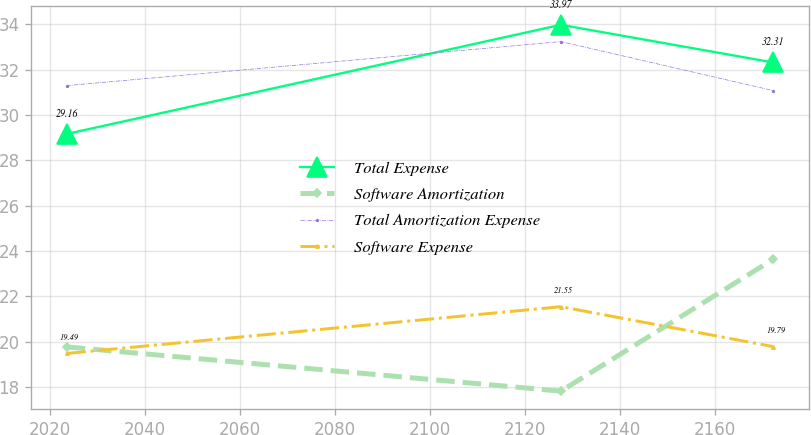Convert chart to OTSL. <chart><loc_0><loc_0><loc_500><loc_500><line_chart><ecel><fcel>Total Expense<fcel>Software Amortization<fcel>Total Amortization Expense<fcel>Software Expense<nl><fcel>2023.6<fcel>29.16<fcel>19.78<fcel>31.29<fcel>19.49<nl><fcel>2127.52<fcel>33.97<fcel>17.83<fcel>33.23<fcel>21.55<nl><fcel>2172.18<fcel>32.31<fcel>23.64<fcel>31.07<fcel>19.79<nl></chart> 